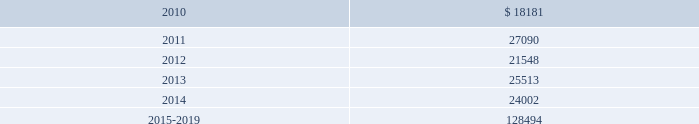Mastercard incorporated notes to consolidated financial statements 2014 ( continued ) ( in thousands , except percent and per share data ) the table summarizes expected benefit payments through 2019 for the pension plans , including those payments expected to be paid from the company 2019s general assets .
Since the majority of the benefit payments are made in the form of lump-sum distributions , actual benefit payments may differ from expected benefit payments. .
Substantially all of the company 2019s u.s .
Employees are eligible to participate in a defined contribution savings plan ( the 201csavings plan 201d ) sponsored by the company .
The savings plan allows employees to contribute a portion of their base compensation on a pre-tax and after-tax basis in accordance with specified guidelines .
The company matches a percentage of employees 2019 contributions up to certain limits .
In 2007 and prior years , the company could also contribute to the savings plan a discretionary profit sharing component linked to company performance during the prior year .
Beginning in 2008 , the discretionary profit sharing amount related to prior year company performance was paid directly to employees as a short-term cash incentive bonus rather than as a contribution to the savings plan .
In addition , the company has several defined contribution plans outside of the united states .
The company 2019s contribution expense related to all of its defined contribution plans was $ 40627 , $ 35341 and $ 26996 for 2009 , 2008 and 2007 , respectively .
Note 13 .
Postemployment and postretirement benefits the company maintains a postretirement plan ( the 201cpostretirement plan 201d ) providing health coverage and life insurance benefits for substantially all of its u.s .
Employees hired before july 1 , 2007 .
The company amended the life insurance benefits under the postretirement plan effective january 1 , 2007 .
The impact , net of taxes , of this amendment was an increase of $ 1715 to accumulated other comprehensive income in 2007 .
In 2009 , the company recorded a $ 3944 benefit expense as a result of enhanced postretirement medical benefits under the postretirement plan provided to employees that chose to participate in a voluntary transition program. .
What was the ratio of the company 2019s contribution expense related to all of its defined contribution plans for 2009 to 2008? 
Computations: (40627 / 35341)
Answer: 1.14957. Mastercard incorporated notes to consolidated financial statements 2014 ( continued ) ( in thousands , except percent and per share data ) the table summarizes expected benefit payments through 2019 for the pension plans , including those payments expected to be paid from the company 2019s general assets .
Since the majority of the benefit payments are made in the form of lump-sum distributions , actual benefit payments may differ from expected benefit payments. .
Substantially all of the company 2019s u.s .
Employees are eligible to participate in a defined contribution savings plan ( the 201csavings plan 201d ) sponsored by the company .
The savings plan allows employees to contribute a portion of their base compensation on a pre-tax and after-tax basis in accordance with specified guidelines .
The company matches a percentage of employees 2019 contributions up to certain limits .
In 2007 and prior years , the company could also contribute to the savings plan a discretionary profit sharing component linked to company performance during the prior year .
Beginning in 2008 , the discretionary profit sharing amount related to prior year company performance was paid directly to employees as a short-term cash incentive bonus rather than as a contribution to the savings plan .
In addition , the company has several defined contribution plans outside of the united states .
The company 2019s contribution expense related to all of its defined contribution plans was $ 40627 , $ 35341 and $ 26996 for 2009 , 2008 and 2007 , respectively .
Note 13 .
Postemployment and postretirement benefits the company maintains a postretirement plan ( the 201cpostretirement plan 201d ) providing health coverage and life insurance benefits for substantially all of its u.s .
Employees hired before july 1 , 2007 .
The company amended the life insurance benefits under the postretirement plan effective january 1 , 2007 .
The impact , net of taxes , of this amendment was an increase of $ 1715 to accumulated other comprehensive income in 2007 .
In 2009 , the company recorded a $ 3944 benefit expense as a result of enhanced postretirement medical benefits under the postretirement plan provided to employees that chose to participate in a voluntary transition program. .
What was the ratio of the benefit payments for 2010 to 2011? 
Computations: (18181 / 27090)
Answer: 0.67113. 